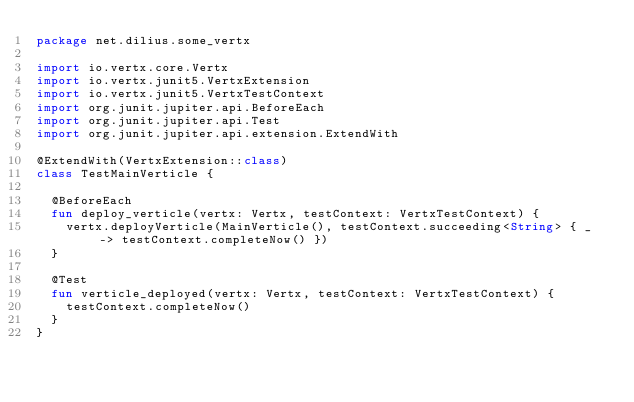<code> <loc_0><loc_0><loc_500><loc_500><_Kotlin_>package net.dilius.some_vertx

import io.vertx.core.Vertx
import io.vertx.junit5.VertxExtension
import io.vertx.junit5.VertxTestContext
import org.junit.jupiter.api.BeforeEach
import org.junit.jupiter.api.Test
import org.junit.jupiter.api.extension.ExtendWith

@ExtendWith(VertxExtension::class)
class TestMainVerticle {

  @BeforeEach
  fun deploy_verticle(vertx: Vertx, testContext: VertxTestContext) {
    vertx.deployVerticle(MainVerticle(), testContext.succeeding<String> { _ -> testContext.completeNow() })
  }

  @Test
  fun verticle_deployed(vertx: Vertx, testContext: VertxTestContext) {
    testContext.completeNow()
  }
}
</code> 